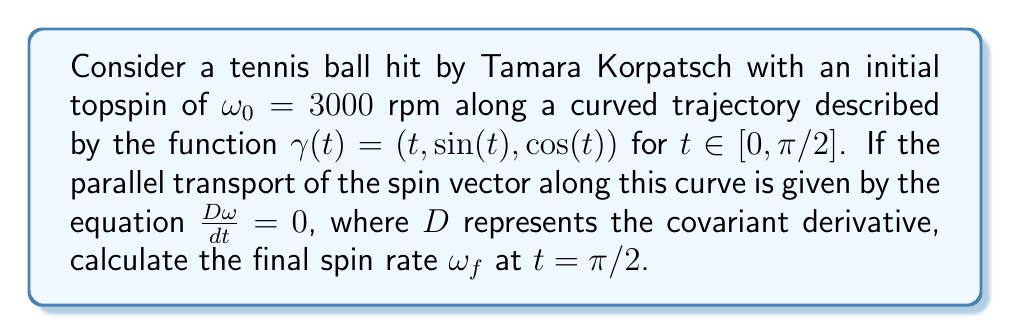What is the answer to this math problem? To solve this problem, we'll follow these steps:

1) The parallel transport equation $\frac{D\omega}{dt} = 0$ implies that the magnitude of the spin vector remains constant along the curve.

2) The curve $\gamma(t) = (t, \sin(t), \cos(t))$ represents a quarter of a helix from $t=0$ to $t=\pi/2$.

3) To visualize this, we can use the following Asymptote diagram:

[asy]
import graph3;
size(200);
currentprojection=perspective(6,3,2);
path3 helix=graph(new triple(real t) {return (t,sin(t),cos(t));},0,pi/2,operator ..);
draw(helix,blue);
draw(O--X,gray+dashed);
draw(O--Y,gray+dashed);
draw(O--Z,gray+dashed);
label("x",X,E);
label("y",Y,N);
label("z",Z,NW);
[/asy]

4) Since the parallel transport preserves the magnitude of the vector, the final spin rate $\omega_f$ at $t = \pi/2$ will be equal to the initial spin rate $\omega_0$.

5) Therefore, $\omega_f = \omega_0 = 3000$ rpm.

It's worth noting that while the magnitude of the spin vector remains constant, its direction in the ambient space changes as it's transported along the curve. However, the question only asks for the spin rate, which is the magnitude of the spin vector.
Answer: $\omega_f = 3000$ rpm 